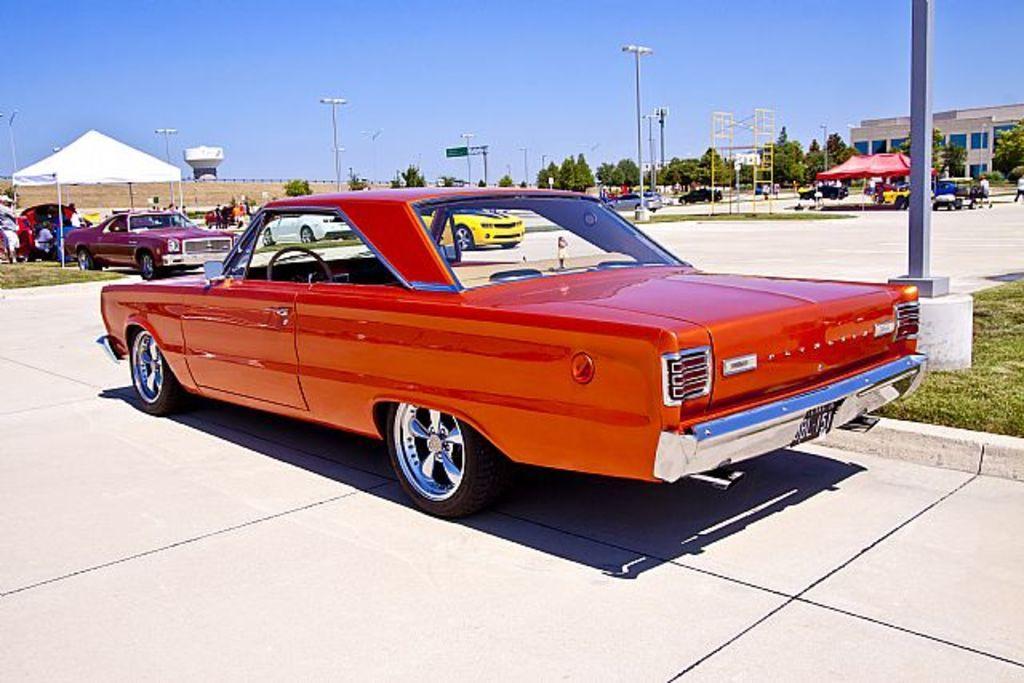Describe this image in one or two sentences. In this picture we can observe a red color car on the road. On the right side there is a pole. We can observe some grass on the ground. In the background there are some cars parked here. We can observe a red color tint. There are buildings. We can observe trees and poles. There is a sky in the background. 